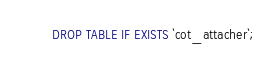<code> <loc_0><loc_0><loc_500><loc_500><_SQL_>DROP TABLE IF EXISTS `cot_attacher`;
</code> 